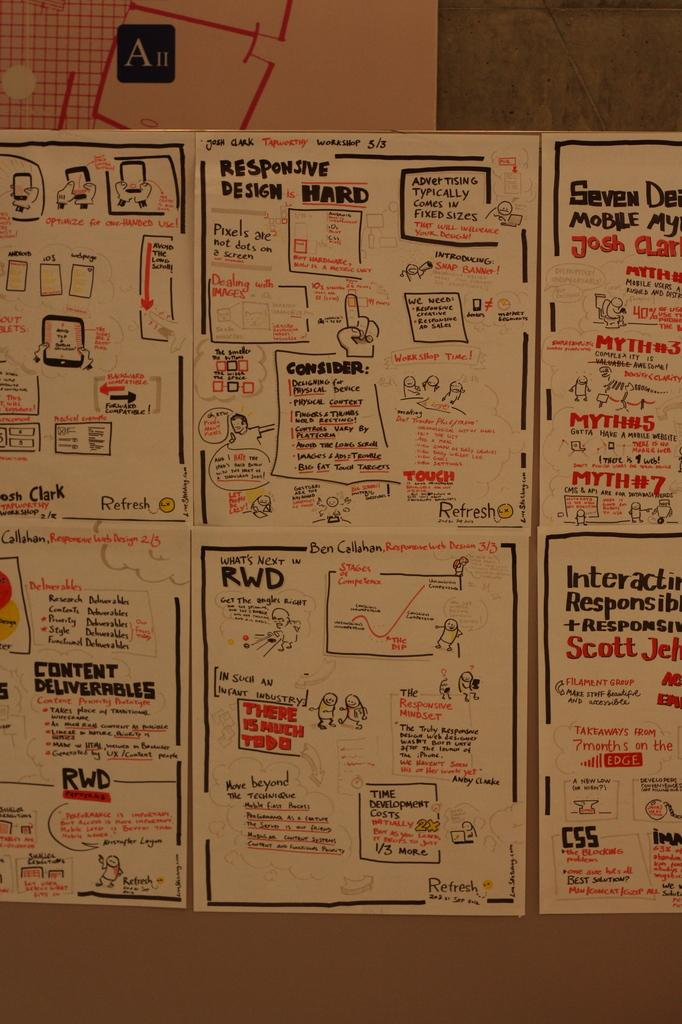Provide a one-sentence caption for the provided image. Handwritten posted signs about Responsive Design is Hard and other game development cartoons and directions. 